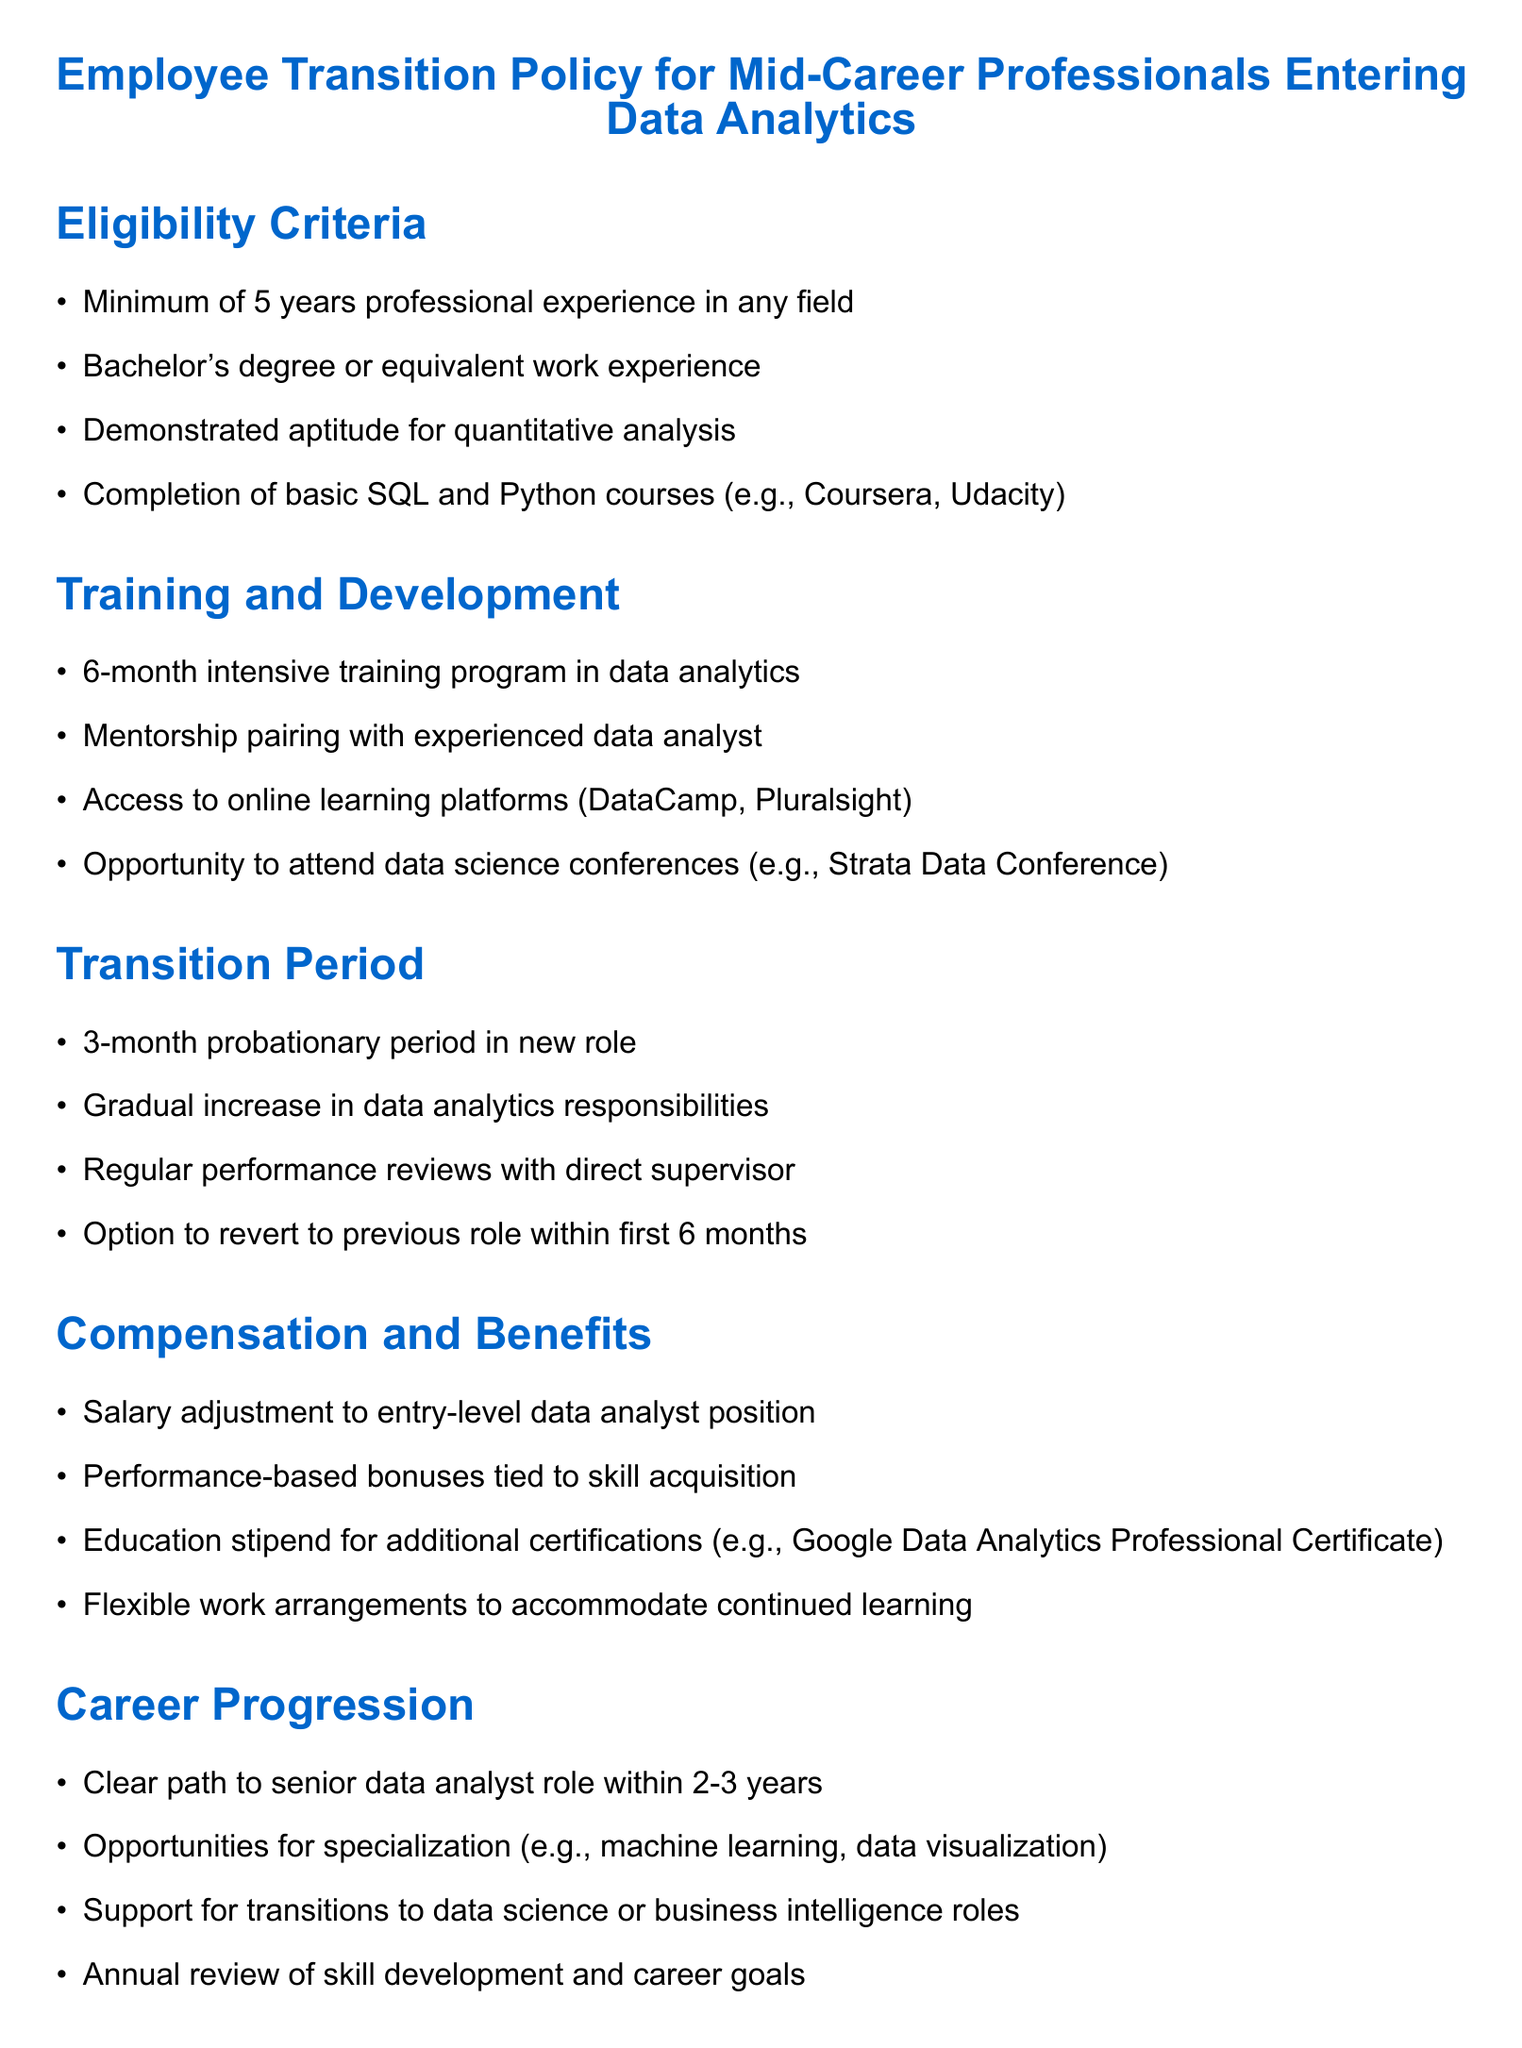What is the minimum professional experience required? The document specifies that a minimum of 5 years of professional experience is required for eligibility.
Answer: 5 years What type of degree is needed for eligibility? The policy states that a Bachelor's degree or equivalent work experience is needed for eligibility.
Answer: Bachelor's degree How long is the intensive training program? According to the document, the intensive training program in data analytics lasts for 6 months.
Answer: 6 months What is the duration of the probationary period? The document mentions a 3-month probationary period in the new role as part of the transition.
Answer: 3 months What is one benefit provided for skill acquisition? The document lists performance-based bonuses as a benefit linked to skill acquisition during the transition.
Answer: Performance-based bonuses What is an opportunity for specialization mentioned in the policy? The document states that opportunities for specialization include machine learning and data visualization.
Answer: Machine learning How long does the document suggest it will take to progress to a senior data analyst role? According to the policy document, it mentions a clear path to the senior data analyst role within 2-3 years.
Answer: 2-3 years Can employees revert to their previous role, and if so, within what time frame? The policy states that there is an option to revert to the previous role within the first 6 months of the transition.
Answer: First 6 months What type of support is mentioned for further career transitions? The document states that there is support for transitions to data science or business intelligence roles.
Answer: Data science or business intelligence roles 